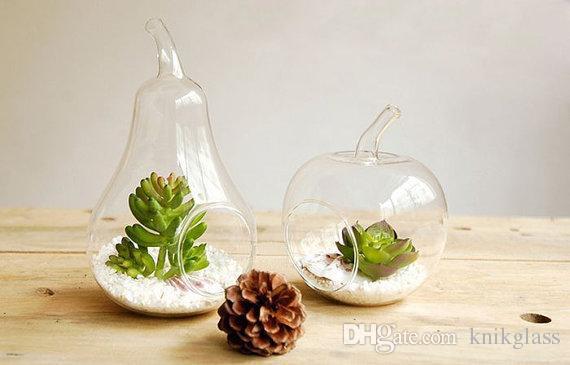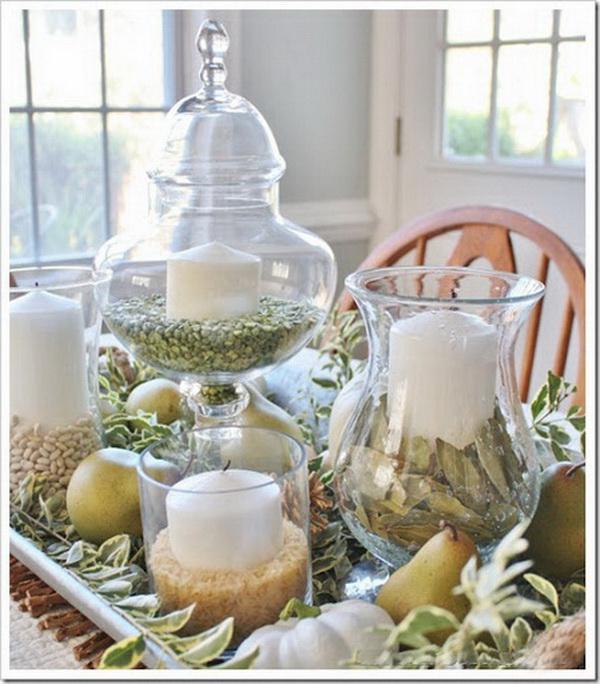The first image is the image on the left, the second image is the image on the right. For the images shown, is this caption "The combined images include a clear container filled with lemons and one filled with apples." true? Answer yes or no. No. 